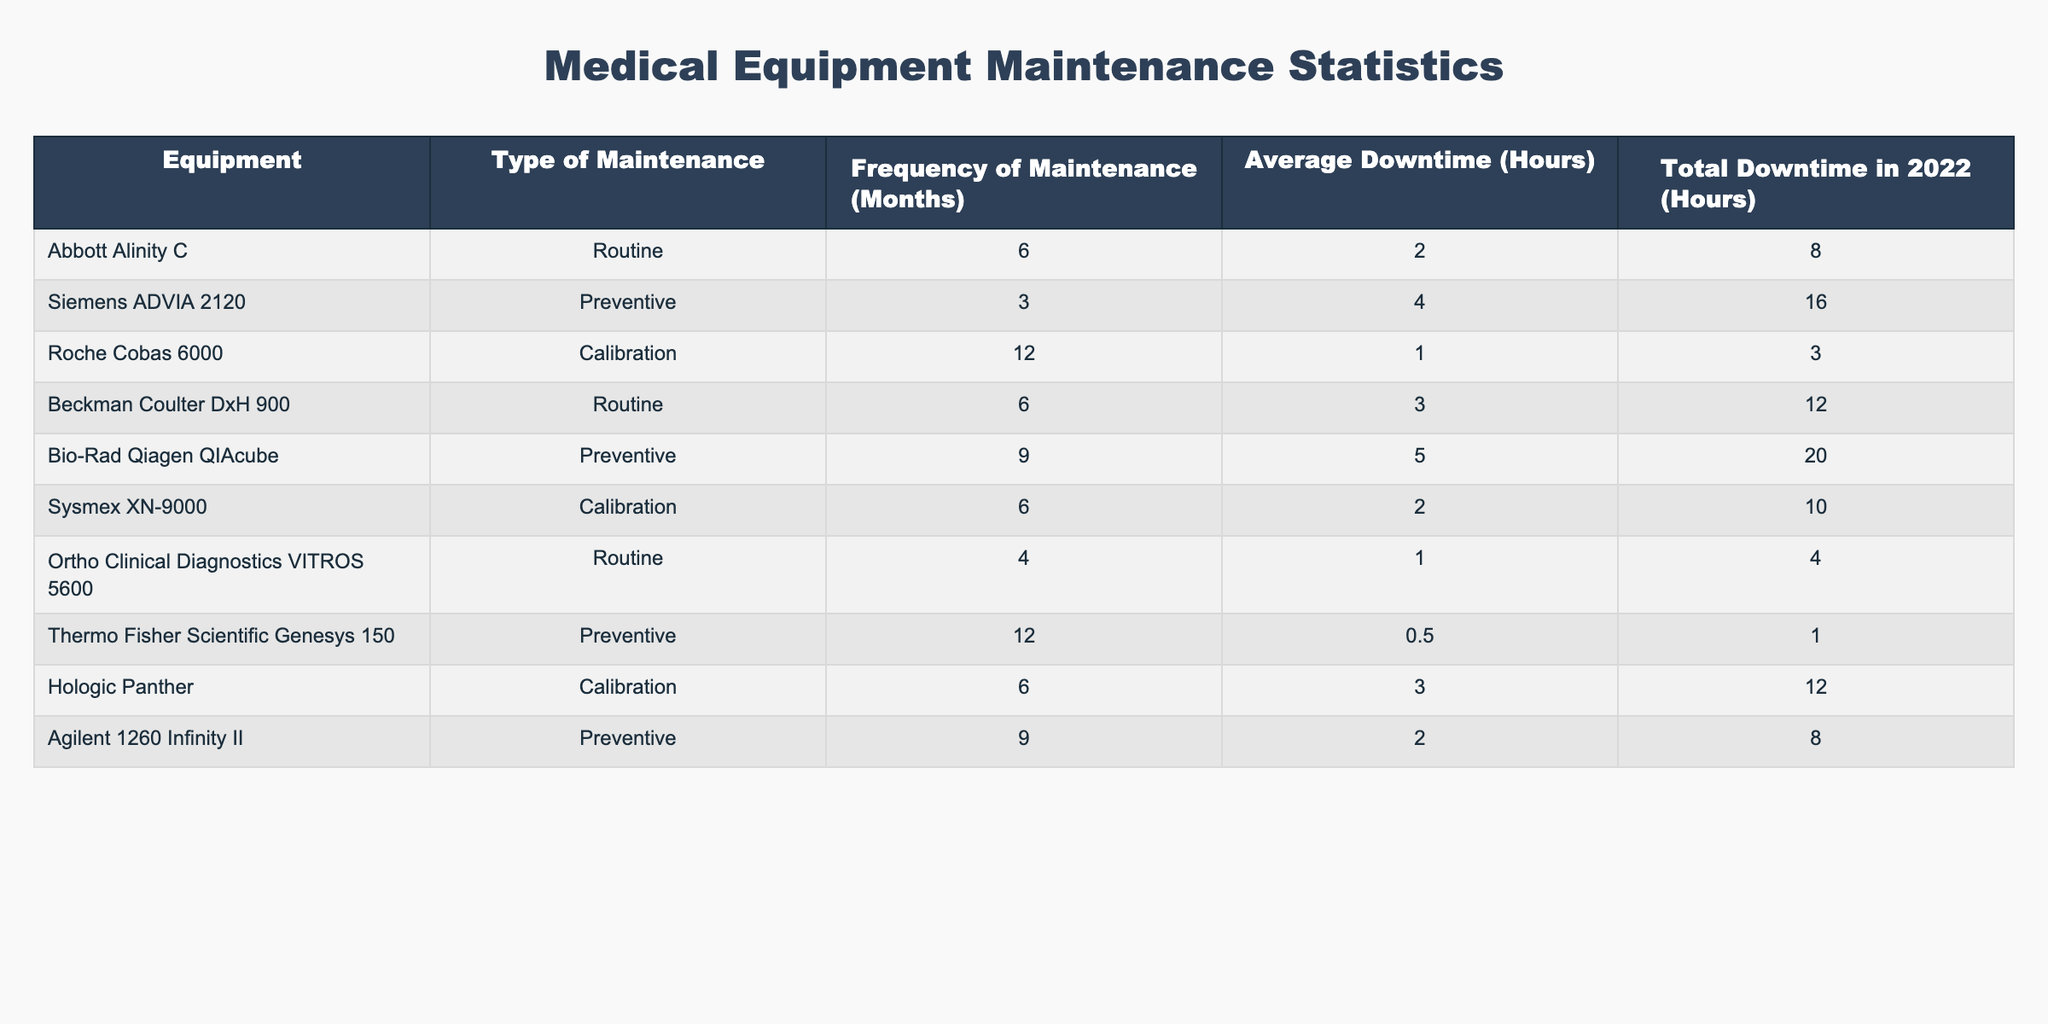What is the average frequency of maintenance across all equipment listed? To find the average frequency of maintenance, I sum up the frequencies of maintenance for each piece of equipment (6 + 3 + 12 + 6 + 9 + 6 + 4 + 12 + 6 + 9) which equals 73. There are 10 entries, so I divide 73 by 10 to get 7.3 months.
Answer: 7.3 How many pieces of equipment require preventive maintenance? By examining the table, I count the entries that have "Preventive" as the type of maintenance. From the list, there are 4 pieces of equipment (Siemens ADVIA 2120, Bio-Rad Qiagen QIAcube, Thermo Fisher Scientific Genesys 150, Agilent 1260 Infinity II).
Answer: 4 What is the total downtime for equipment needing routine maintenance? I first identify the equipment that undergo routine maintenance: Abbott Alinity C, Beckman Coulter DxH 900, and Ortho Clinical Diagnostics VITROS 5600. Their total downtimes are 8 + 12 + 4 = 24 hours.
Answer: 24 Is the average downtime for calibration maintenance less than that for routine maintenance? To answer this, I calculate the average downtime for both types. Calibration entries (Roche Cobas 6000, Sysmex XN-9000, Hologic Panther) have total downtimes of 3 + 10 + 12 = 25 hours over 3 entries, giving an average of 25/3 ≈ 8.33 hours. The routine entries (Abbott Alinity C, Beckman Coulter DxH 900, Ortho Clinical Diagnostics VITROS 5600) total 24 hours over 3 entries, giving an average of 24/3 = 8 hours. Since 8.33 > 8, the statement is false.
Answer: No Which equipment has the highest average downtime? I review all average downtimes provided: Abbott Alinity C (2), Siemens ADVIA 2120 (4), Roche Cobas 6000 (1), Beckman Coulter DxH 900 (3), Bio-Rad Qiagen QIAcube (5), Sysmex XN-9000 (2), Ortho Clinical Diagnostics VITROS 5600 (1), Thermo Fisher Scientific Genesys 150 (0.5), Hologic Panther (3), Agilent 1260 Infinity II (2). The highest average downtime is 5 hours for Bio-Rad Qiagen QIAcube.
Answer: Bio-Rad Qiagen QIAcube What type of maintenance is most common among the listed equipment? Looking at the maintenance types in the table, I count: Routine (3), Preventive (4), Calibration (3). The type "Preventive" has the highest count of 4.
Answer: Preventive 